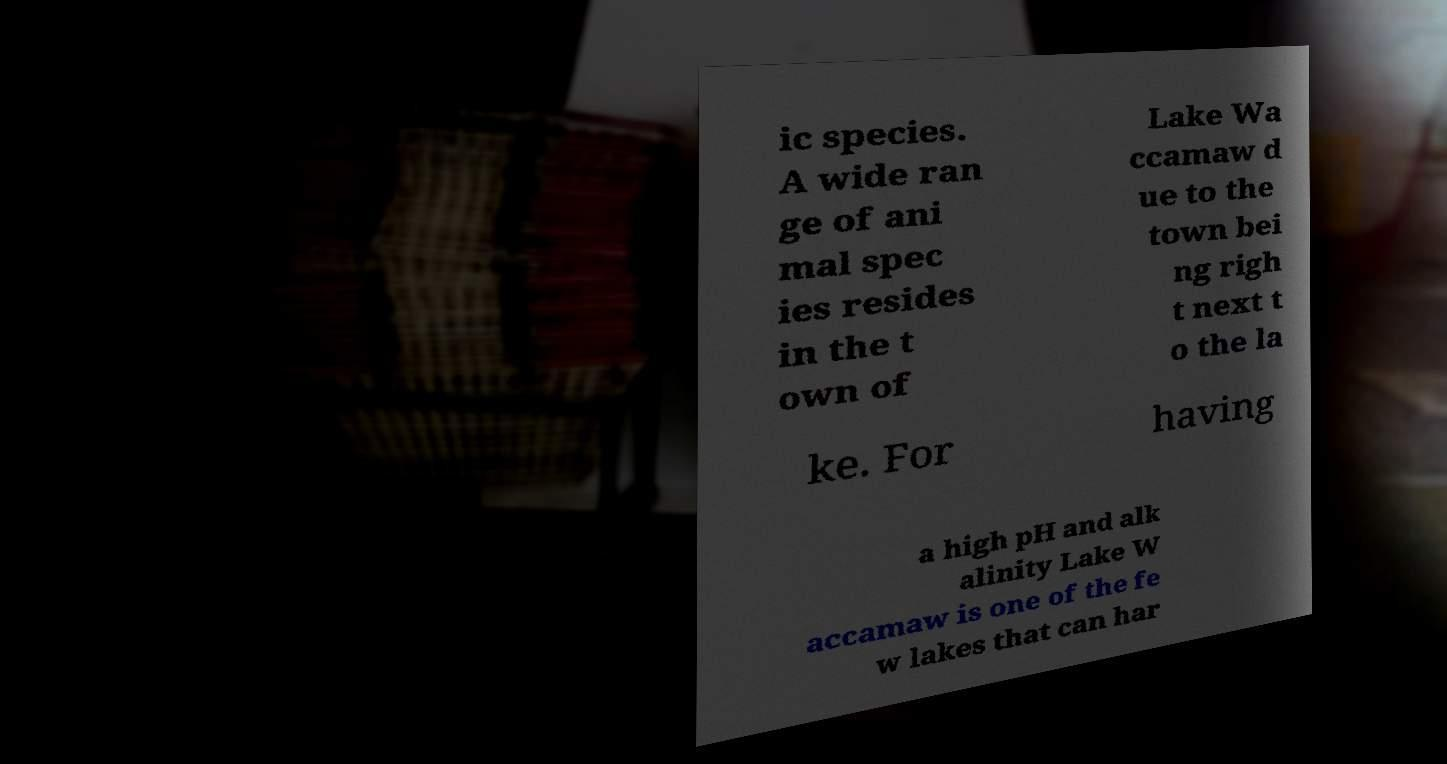Can you accurately transcribe the text from the provided image for me? ic species. A wide ran ge of ani mal spec ies resides in the t own of Lake Wa ccamaw d ue to the town bei ng righ t next t o the la ke. For having a high pH and alk alinity Lake W accamaw is one of the fe w lakes that can har 